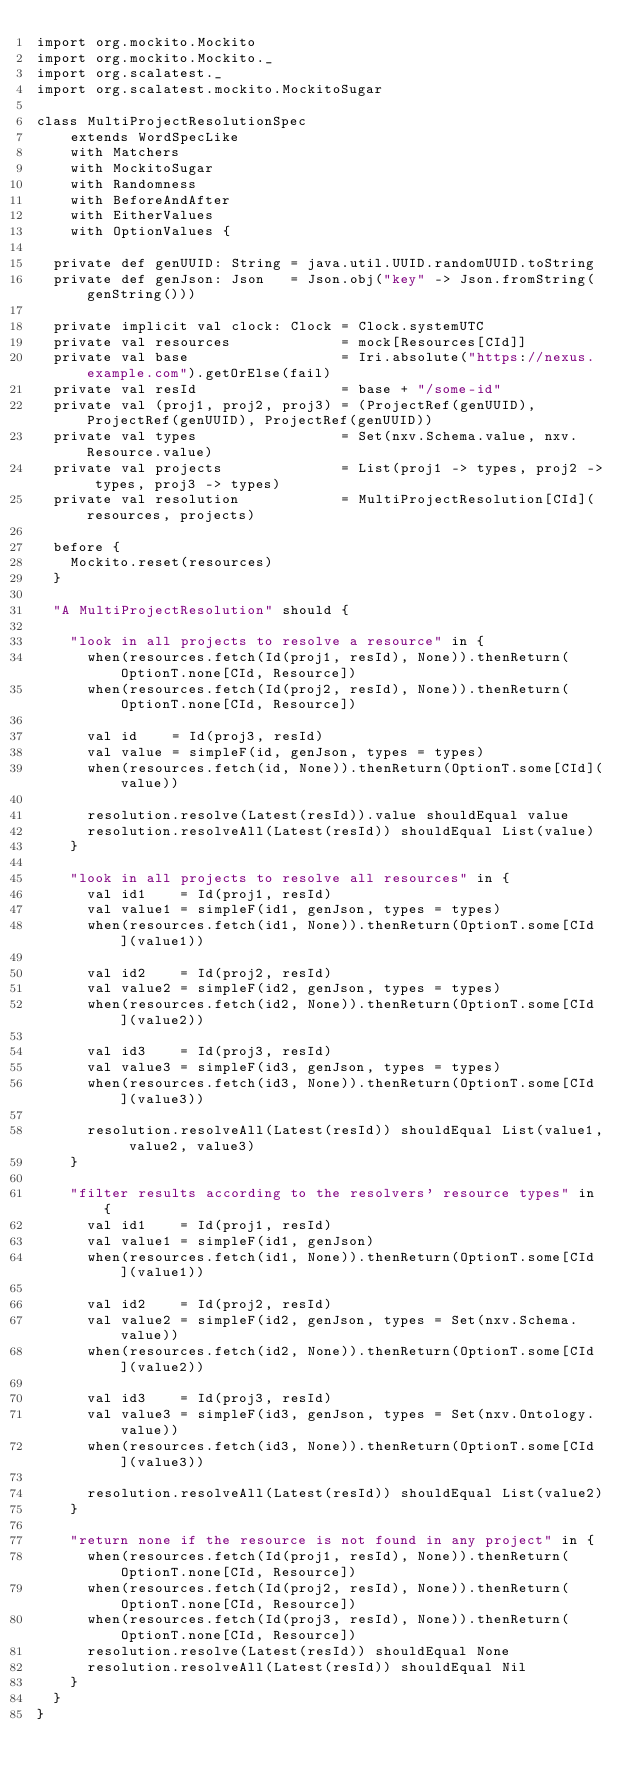Convert code to text. <code><loc_0><loc_0><loc_500><loc_500><_Scala_>import org.mockito.Mockito
import org.mockito.Mockito._
import org.scalatest._
import org.scalatest.mockito.MockitoSugar

class MultiProjectResolutionSpec
    extends WordSpecLike
    with Matchers
    with MockitoSugar
    with Randomness
    with BeforeAndAfter
    with EitherValues
    with OptionValues {

  private def genUUID: String = java.util.UUID.randomUUID.toString
  private def genJson: Json   = Json.obj("key" -> Json.fromString(genString()))

  private implicit val clock: Clock = Clock.systemUTC
  private val resources             = mock[Resources[CId]]
  private val base                  = Iri.absolute("https://nexus.example.com").getOrElse(fail)
  private val resId                 = base + "/some-id"
  private val (proj1, proj2, proj3) = (ProjectRef(genUUID), ProjectRef(genUUID), ProjectRef(genUUID))
  private val types                 = Set(nxv.Schema.value, nxv.Resource.value)
  private val projects              = List(proj1 -> types, proj2 -> types, proj3 -> types)
  private val resolution            = MultiProjectResolution[CId](resources, projects)

  before {
    Mockito.reset(resources)
  }

  "A MultiProjectResolution" should {

    "look in all projects to resolve a resource" in {
      when(resources.fetch(Id(proj1, resId), None)).thenReturn(OptionT.none[CId, Resource])
      when(resources.fetch(Id(proj2, resId), None)).thenReturn(OptionT.none[CId, Resource])

      val id    = Id(proj3, resId)
      val value = simpleF(id, genJson, types = types)
      when(resources.fetch(id, None)).thenReturn(OptionT.some[CId](value))

      resolution.resolve(Latest(resId)).value shouldEqual value
      resolution.resolveAll(Latest(resId)) shouldEqual List(value)
    }

    "look in all projects to resolve all resources" in {
      val id1    = Id(proj1, resId)
      val value1 = simpleF(id1, genJson, types = types)
      when(resources.fetch(id1, None)).thenReturn(OptionT.some[CId](value1))

      val id2    = Id(proj2, resId)
      val value2 = simpleF(id2, genJson, types = types)
      when(resources.fetch(id2, None)).thenReturn(OptionT.some[CId](value2))

      val id3    = Id(proj3, resId)
      val value3 = simpleF(id3, genJson, types = types)
      when(resources.fetch(id3, None)).thenReturn(OptionT.some[CId](value3))

      resolution.resolveAll(Latest(resId)) shouldEqual List(value1, value2, value3)
    }

    "filter results according to the resolvers' resource types" in {
      val id1    = Id(proj1, resId)
      val value1 = simpleF(id1, genJson)
      when(resources.fetch(id1, None)).thenReturn(OptionT.some[CId](value1))

      val id2    = Id(proj2, resId)
      val value2 = simpleF(id2, genJson, types = Set(nxv.Schema.value))
      when(resources.fetch(id2, None)).thenReturn(OptionT.some[CId](value2))

      val id3    = Id(proj3, resId)
      val value3 = simpleF(id3, genJson, types = Set(nxv.Ontology.value))
      when(resources.fetch(id3, None)).thenReturn(OptionT.some[CId](value3))

      resolution.resolveAll(Latest(resId)) shouldEqual List(value2)
    }

    "return none if the resource is not found in any project" in {
      when(resources.fetch(Id(proj1, resId), None)).thenReturn(OptionT.none[CId, Resource])
      when(resources.fetch(Id(proj2, resId), None)).thenReturn(OptionT.none[CId, Resource])
      when(resources.fetch(Id(proj3, resId), None)).thenReturn(OptionT.none[CId, Resource])
      resolution.resolve(Latest(resId)) shouldEqual None
      resolution.resolveAll(Latest(resId)) shouldEqual Nil
    }
  }
}
</code> 